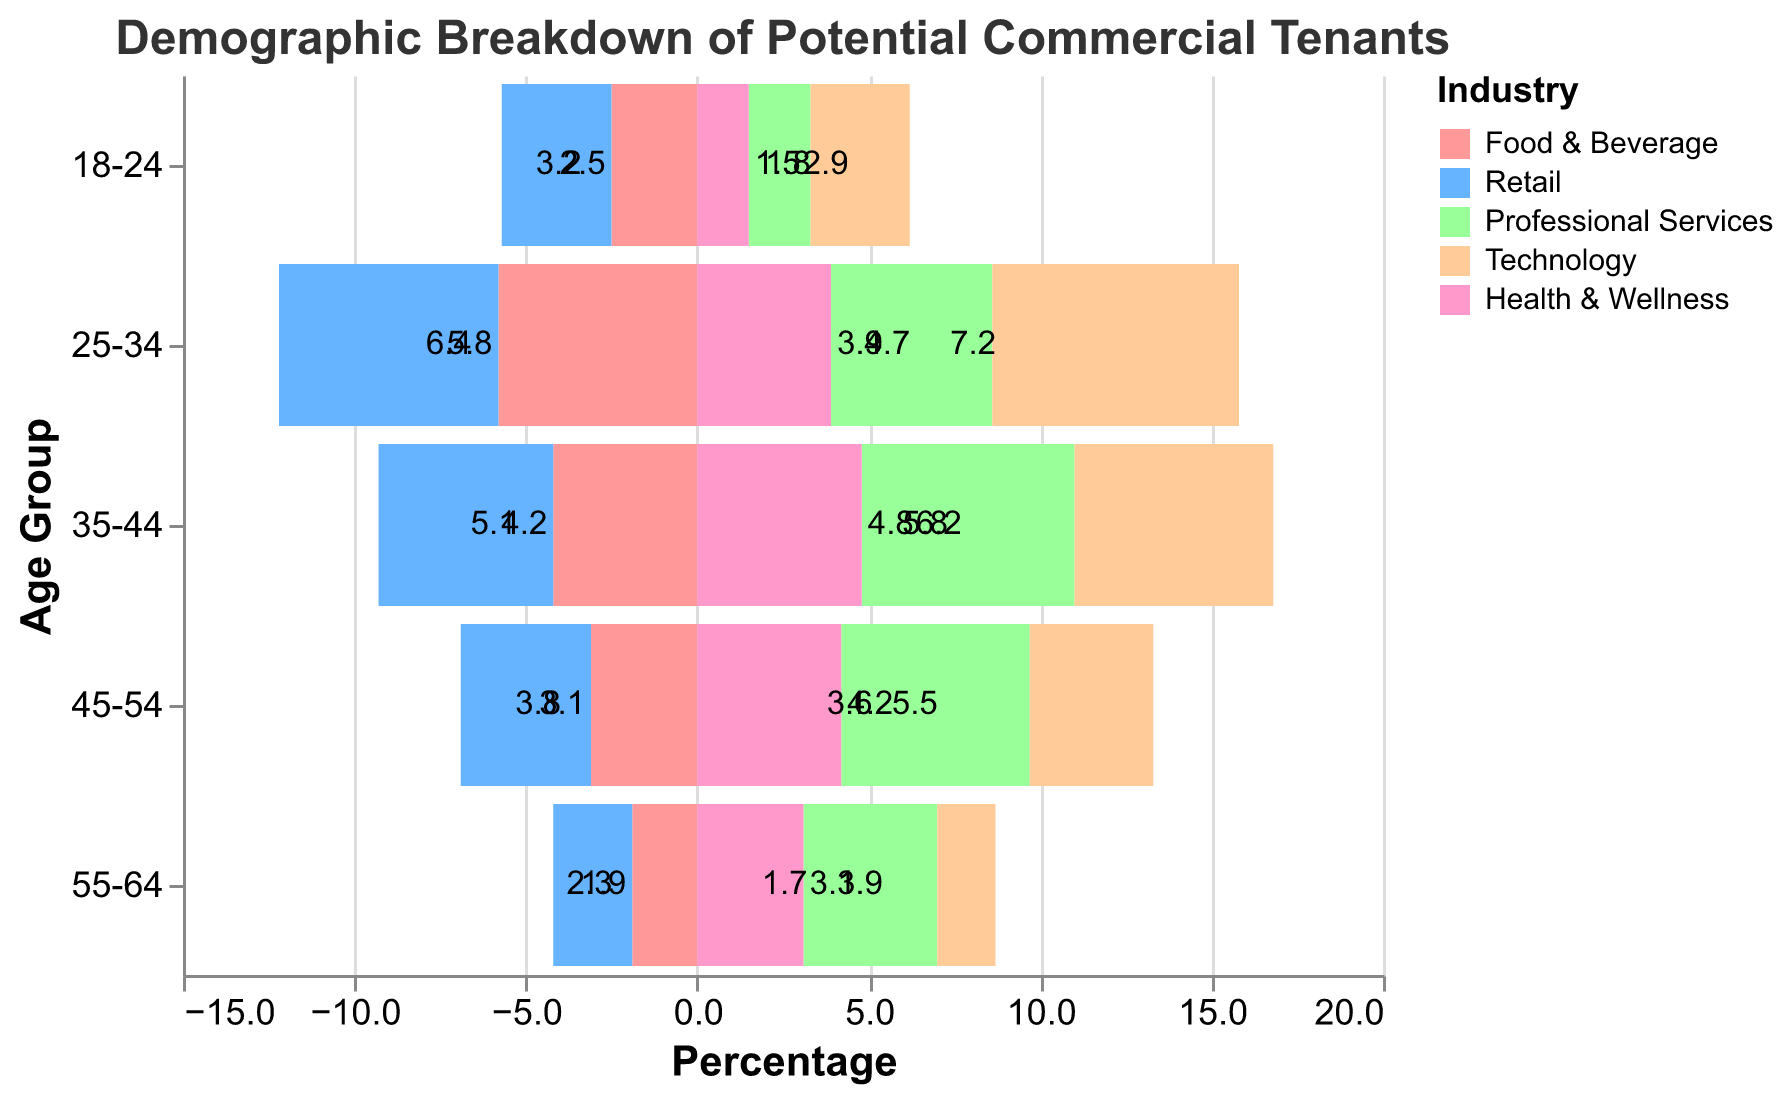What's the title of the figure? The title of a figure is typically found at the top, center, and describes the overall subject of the visual. According to our data, the title is "Demographic Breakdown of Potential Commercial Tenants."
Answer: Demographic Breakdown of Potential Commercial Tenants Which age group has the highest percentage in the Technology industry? To find this, we look at the bars labeled for the Technology industry and identify which age group has the longest bar (highest percentage). According to the data, it's the "25-34" age group with 7.2%.
Answer: 25-34 What is the range of percentages represented for the Health & Wellness industry? To determine the range, we find the highest and lowest percentages for the Health & Wellness industry. The highest is 4.8% (35-44) and the lowest is 1.5% (18-24). The range is the difference between them: 4.8 - 1.5 = 3.3%.
Answer: 3.3% Compare the percentage of tenants in the "45-54" age group between the Retail and Food & Beverage industries. Which is higher? We find the "45-54" percentages for both industries: Retail is 3.8% and Food & Beverage is 3.1%. Comparing these, Retail has a higher percentage than Food & Beverage.
Answer: Retail In which industry do people aged 35-44 occupy the largest percentage? Looking at the percentages in the "35-44" age group across all industries, we see that Professional Services has the highest value at 6.2%.
Answer: Professional Services Summarize the total percentage of potential tenants in the 25-34 age group across all industries. We sum the percentages for the 25-34 age group: Food & Beverage (5.8%), Retail (6.4%), Professional Services (4.7%), Technology (7.2%), Health & Wellness (3.9%). The total is 5.8 + 6.4 + 4.7 + 7.2 + 3.9 = 28%.
Answer: 28% Which industry has the smallest presence in the "55-64" age group? Reviewing the percentages for the "55-64" age group across industries, Technology at 1.7% is the smallest presence.
Answer: Technology For the Food & Beverage industry, what is the combined percentage of tenants aged 18-34? We add the percentages for 18-24 (2.5%) and 25-34 (5.8%) in Food & Beverage: 2.5 + 5.8 = 8.3%.
Answer: 8.3% What's the difference between the highest percentage and lowest percentage in the Technology industry? The highest percentage in Technology is 7.2% (25-34), and the lowest is 1.7% (55-64). The difference is 7.2 - 1.7 = 5.5%.
Answer: 5.5% How do the percentages for the "35-44" age group in Professional Services and Health & Wellness compare? Professional Services has a "35-44" percentage of 6.2%, and Health & Wellness has 4.8% for the same age group. Professional Services has a higher percentage.
Answer: Professional Services 